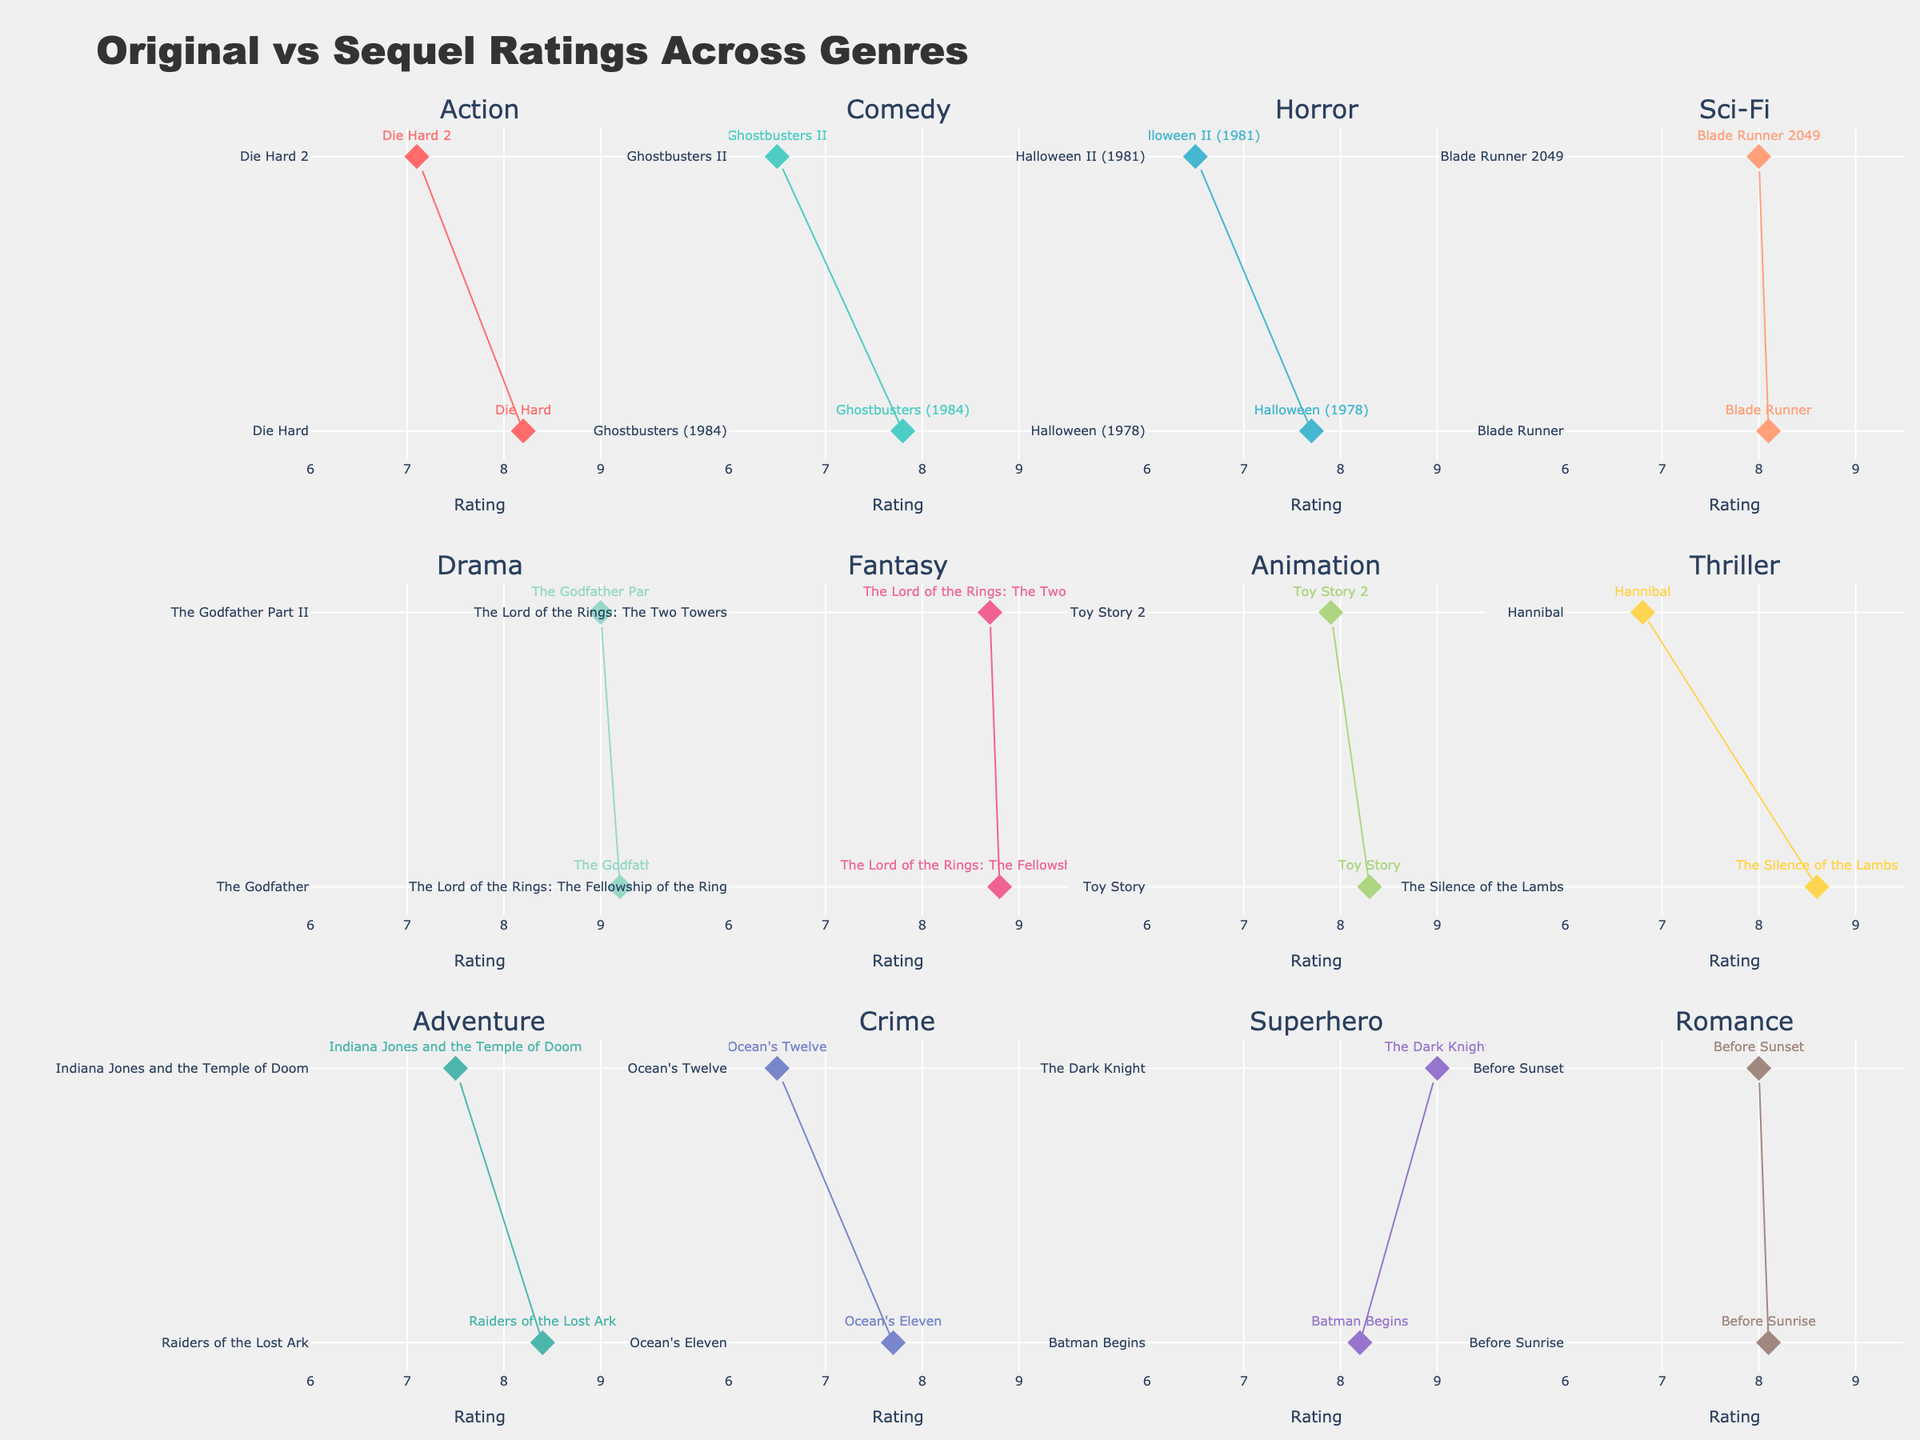How many genres are represented in the figure? The subplot titles indicate different genres. Count the number of unique genres represented in the titles of the subplots.
Answer: 12 Which film genre has the smallest difference between the original and its sequel ratings? Compare the differences between original and sequel ratings for each genre. The genres are Drama, Sci-Fi, and Romance (0.2, 0.1, 0.1). Romance and Sci-Fi both have a difference of 0.1, which is the smallest overall.
Answer: Sci-Fi and Romance What is the title of the subplot located in the third row, third column? Locate the subplot in the specified row and column, then check the title of that subplot.
Answer: Superhero Between the "Action" and "Comedy" genres, which has the largest drop in rating from original to sequel? Calculate the difference in ratings for both genres. For Action, it is 8.2 - 7.1 = 1.1; for Comedy, it is 7.8 - 6.5 = 1.3. Compare these differences.
Answer: Comedy Which genre has the highest original rating and what is that rating? Identify the highest value on the x-axis among all genres, and determine the genre associated with that value.
Answer: Drama, 9.2 In which genre does the sequel have a higher rating than the original? Compare the sequel ratings to the original ratings across genres. The "Superhero" genre with "Batman Begins" at 8.2 and "The Dark Knight" at 9.0 qualifies.
Answer: Superhero Which genre has both the lowest rated original and its sequel? Among the genres, compare the ratings of original and sequel pairs, and find the lowest combined rating. "Crime" has original 7.7 and sequel 6.5, resulting in a combined rating of 14.2, which is the lowest.
Answer: Crime How many genres have the sequels rated lower than the originals? Count the number of genres where the sequel rating is less than the original rating by inspecting arrow directions (downwards).
Answer: 10 What is the average rating difference between the original and sequels across all genres? Compute the rating differences for each genre, sum these differences, and divide by the number of genres (12). Difference totals to 13.1. Average is 13.1 / 12 ≈ 1.1
Answer: 1.1 Which two genres have the smallest and largest rating drop from the original to the sequel? Determine the genres with the smallest (Sci-Fi/Romance at 0.1) and the largest (Thriller at 1.8) rating drop by comparing each genre's drop values.
Answer: Sci-Fi/Romance and Thriller 